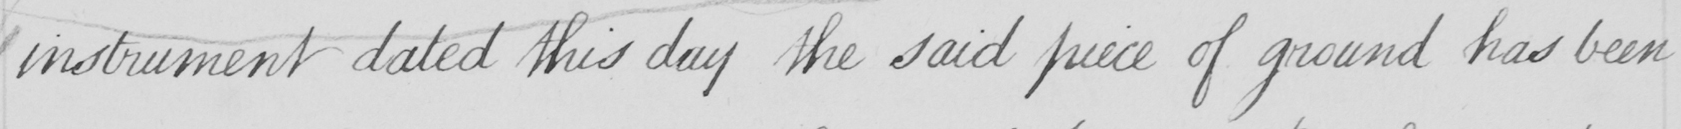What does this handwritten line say? instrument dated this day the said piece of ground has been 